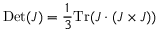<formula> <loc_0><loc_0><loc_500><loc_500>D e t ( J ) = \frac { 1 } { 3 } T r ( J \cdot ( J \times J ) )</formula> 